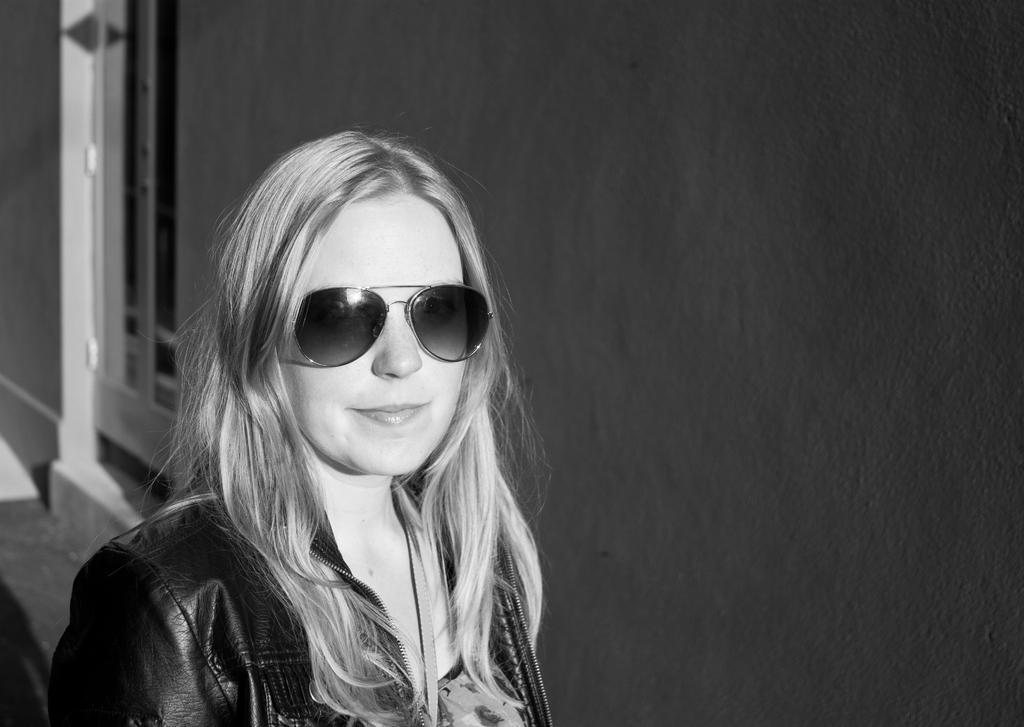In one or two sentences, can you explain what this image depicts? It is the black and white image of a woman. In the background there is a wall with the window. 